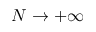Convert formula to latex. <formula><loc_0><loc_0><loc_500><loc_500>N \to + \infty</formula> 